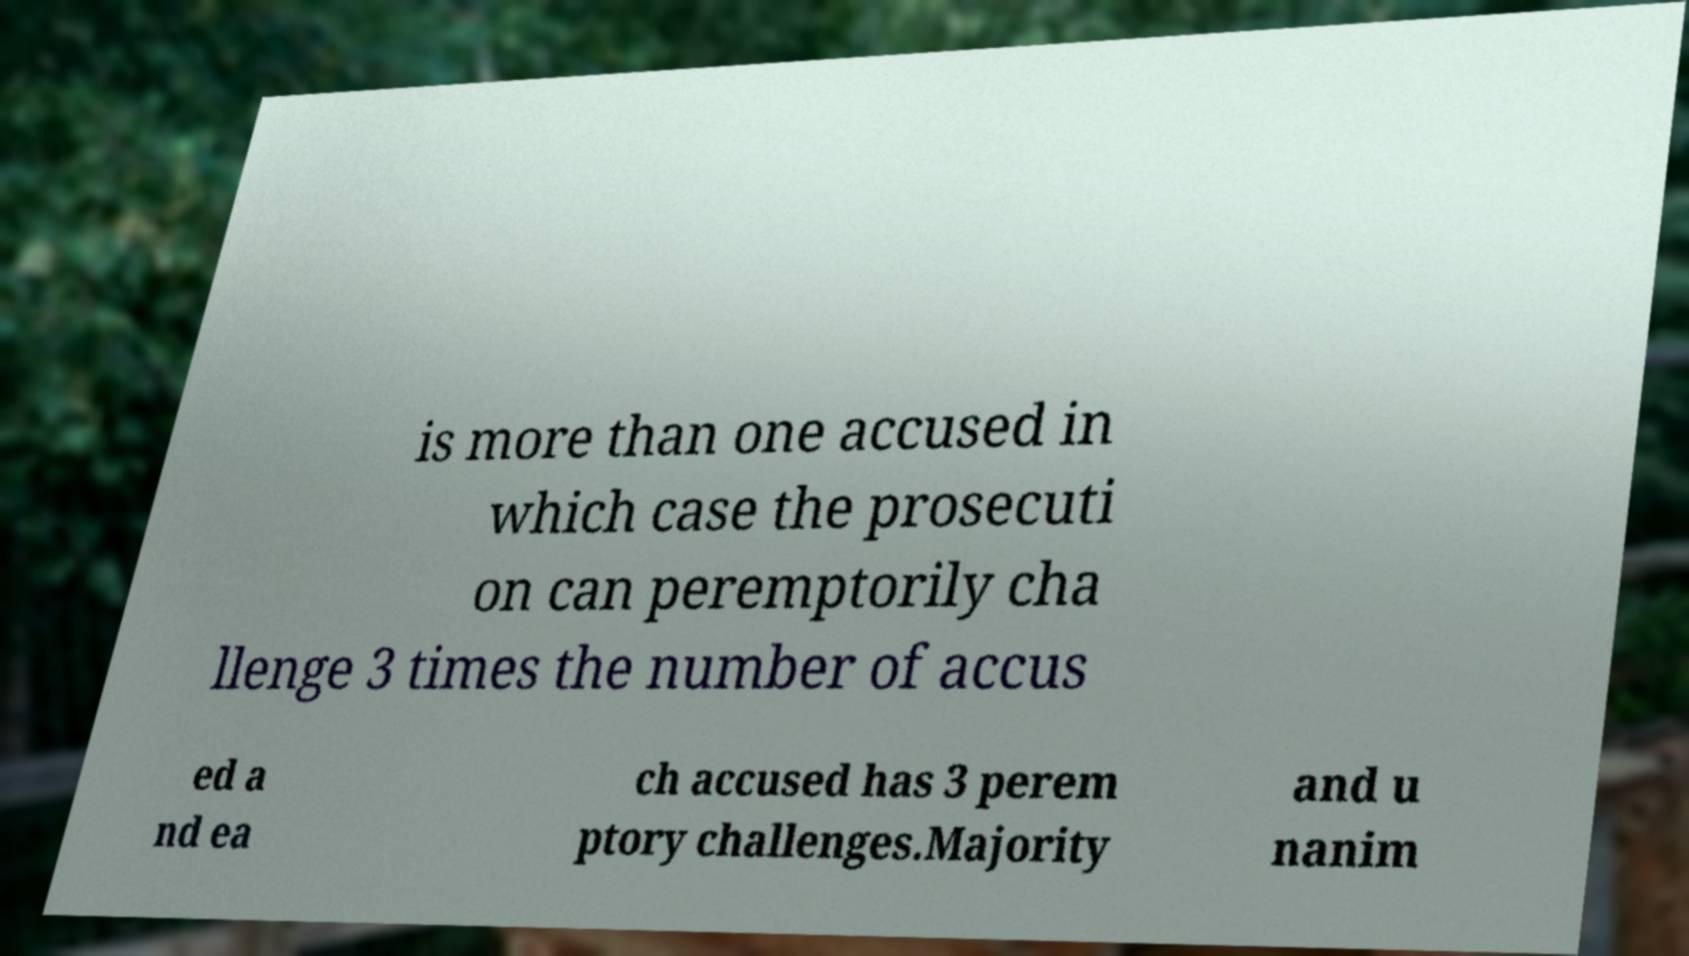Please identify and transcribe the text found in this image. is more than one accused in which case the prosecuti on can peremptorily cha llenge 3 times the number of accus ed a nd ea ch accused has 3 perem ptory challenges.Majority and u nanim 